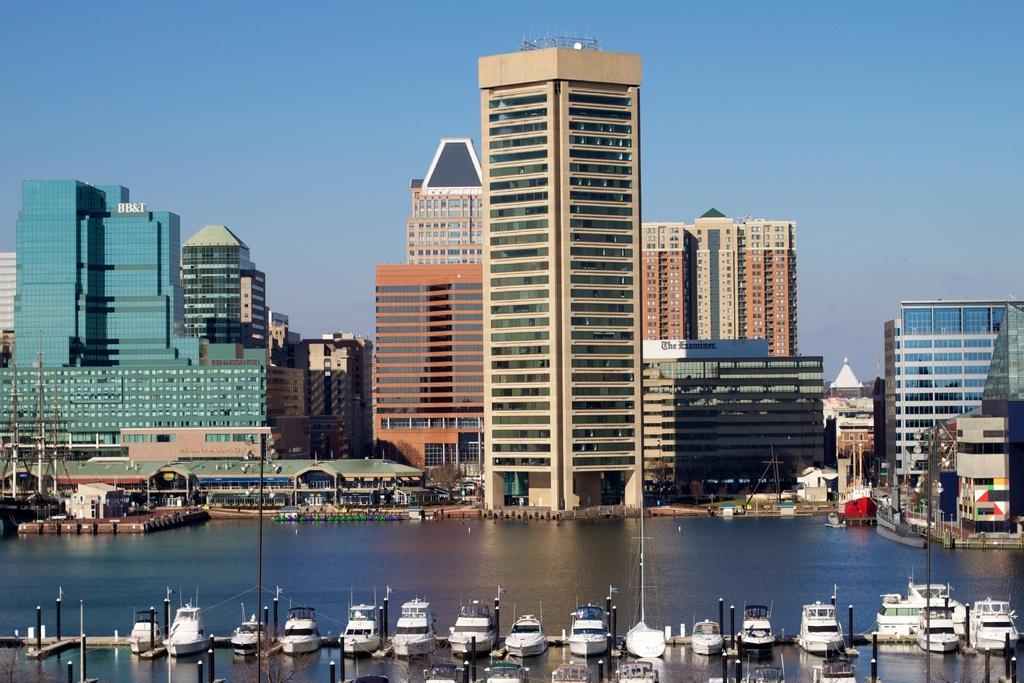Could you give a brief overview of what you see in this image? There are boats on the water. In the background, there are buildings which are having glass windows and there is blue sky. 